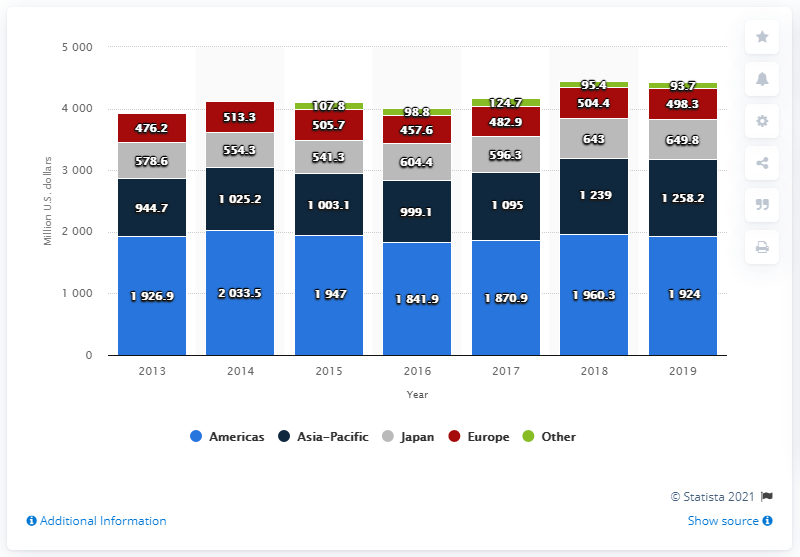Give some essential details in this illustration. In 2019, the net sales of Tiffany & Co. in the Americas region totaled 1924. 